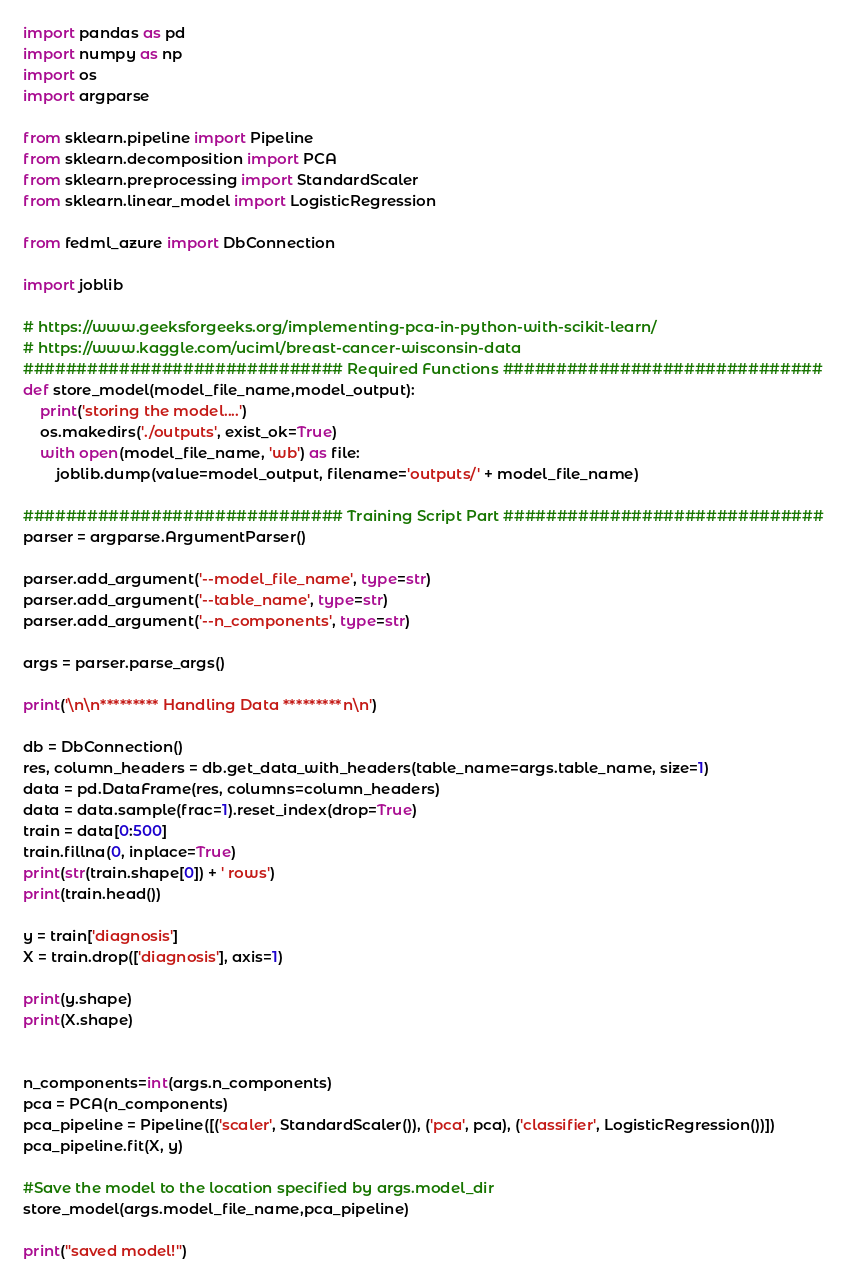<code> <loc_0><loc_0><loc_500><loc_500><_Python_>import pandas as pd
import numpy as np
import os
import argparse

from sklearn.pipeline import Pipeline
from sklearn.decomposition import PCA
from sklearn.preprocessing import StandardScaler
from sklearn.linear_model import LogisticRegression

from fedml_azure import DbConnection

import joblib

# https://www.geeksforgeeks.org/implementing-pca-in-python-with-scikit-learn/
# https://www.kaggle.com/uciml/breast-cancer-wisconsin-data
############################## Required Functions ##############################
def store_model(model_file_name,model_output):
    print('storing the model....')
    os.makedirs('./outputs', exist_ok=True)
    with open(model_file_name, 'wb') as file:
        joblib.dump(value=model_output, filename='outputs/' + model_file_name)
    
############################## Training Script Part ##############################
parser = argparse.ArgumentParser()

parser.add_argument('--model_file_name', type=str)
parser.add_argument('--table_name', type=str)
parser.add_argument('--n_components', type=str)

args = parser.parse_args()

print('\n\n********* Handling Data *********n\n')

db = DbConnection()
res, column_headers = db.get_data_with_headers(table_name=args.table_name, size=1)
data = pd.DataFrame(res, columns=column_headers)
data = data.sample(frac=1).reset_index(drop=True)
train = data[0:500]
train.fillna(0, inplace=True)
print(str(train.shape[0]) + ' rows')
print(train.head())

y = train['diagnosis']
X = train.drop(['diagnosis'], axis=1)

print(y.shape)
print(X.shape)


n_components=int(args.n_components)
pca = PCA(n_components)
pca_pipeline = Pipeline([('scaler', StandardScaler()), ('pca', pca), ('classifier', LogisticRegression())])
pca_pipeline.fit(X, y)

#Save the model to the location specified by args.model_dir
store_model(args.model_file_name,pca_pipeline)

print("saved model!")


</code> 